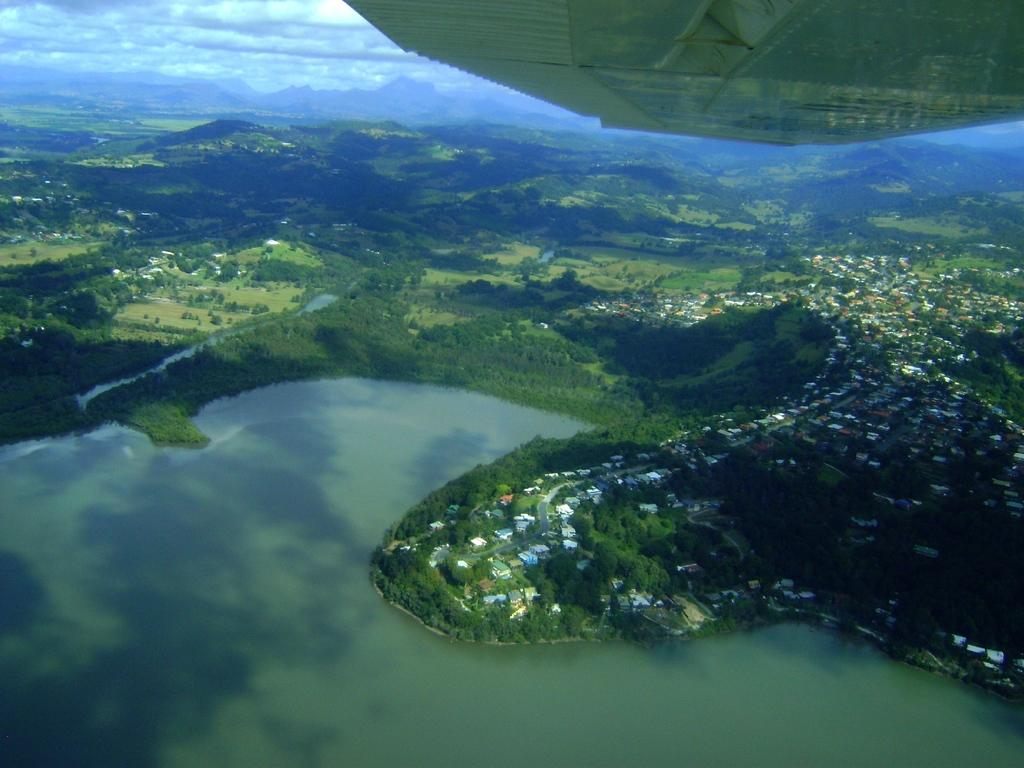What is the main feature of the landscape in the image? There is a large water body in the image. What type of vegetation can be seen in the image? There is a group of trees in the image. What type of structures are present in the image? There are buildings in the image. What geographical features can be seen in the image? There are hills visible in the image. What is the weather like in the image? The sky is cloudy in the image. Can you describe any transportation-related elements in the image? The wing of an airplane is visible at the top of the image. How many flowers are present in the image? There are no flowers visible in the image. What type of cannon is being fired in the image? There is no cannon present in the image. 